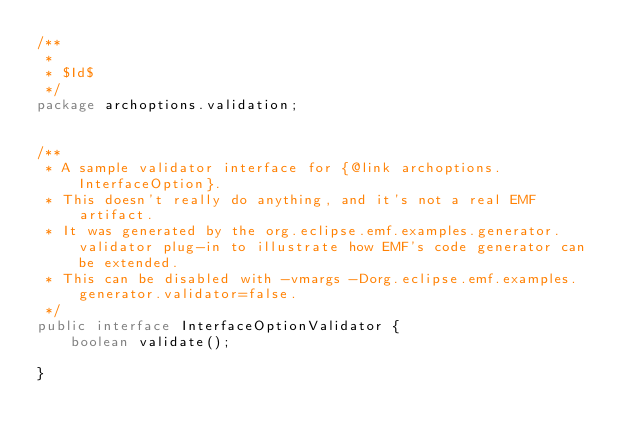Convert code to text. <code><loc_0><loc_0><loc_500><loc_500><_Java_>/**
 *
 * $Id$
 */
package archoptions.validation;


/**
 * A sample validator interface for {@link archoptions.InterfaceOption}.
 * This doesn't really do anything, and it's not a real EMF artifact.
 * It was generated by the org.eclipse.emf.examples.generator.validator plug-in to illustrate how EMF's code generator can be extended.
 * This can be disabled with -vmargs -Dorg.eclipse.emf.examples.generator.validator=false.
 */
public interface InterfaceOptionValidator {
	boolean validate();

}
</code> 